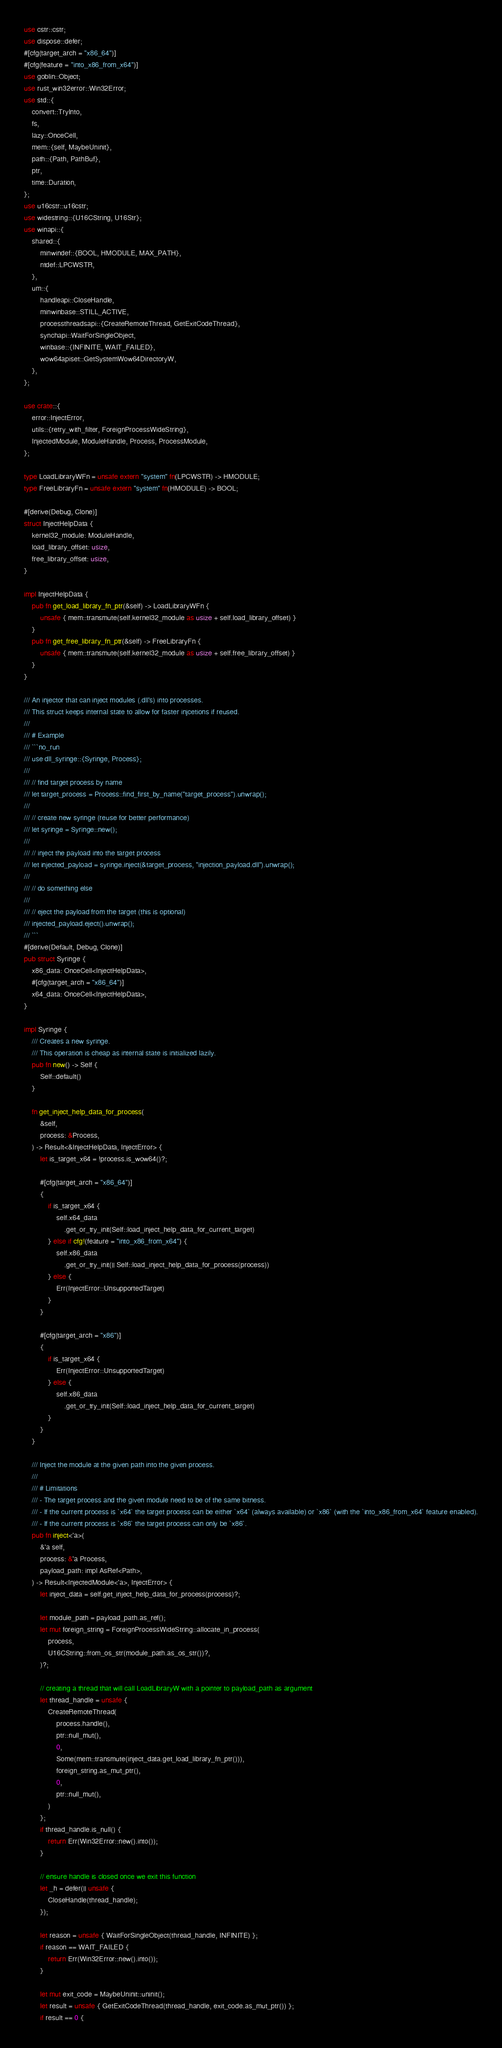<code> <loc_0><loc_0><loc_500><loc_500><_Rust_>use cstr::cstr;
use dispose::defer;
#[cfg(target_arch = "x86_64")]
#[cfg(feature = "into_x86_from_x64")]
use goblin::Object;
use rust_win32error::Win32Error;
use std::{
    convert::TryInto,
    fs,
    lazy::OnceCell,
    mem::{self, MaybeUninit},
    path::{Path, PathBuf},
    ptr,
    time::Duration,
};
use u16cstr::u16cstr;
use widestring::{U16CString, U16Str};
use winapi::{
    shared::{
        minwindef::{BOOL, HMODULE, MAX_PATH},
        ntdef::LPCWSTR,
    },
    um::{
        handleapi::CloseHandle,
        minwinbase::STILL_ACTIVE,
        processthreadsapi::{CreateRemoteThread, GetExitCodeThread},
        synchapi::WaitForSingleObject,
        winbase::{INFINITE, WAIT_FAILED},
        wow64apiset::GetSystemWow64DirectoryW,
    },
};

use crate::{
    error::InjectError,
    utils::{retry_with_filter, ForeignProcessWideString},
    InjectedModule, ModuleHandle, Process, ProcessModule,
};

type LoadLibraryWFn = unsafe extern "system" fn(LPCWSTR) -> HMODULE;
type FreeLibraryFn = unsafe extern "system" fn(HMODULE) -> BOOL;

#[derive(Debug, Clone)]
struct InjectHelpData {
    kernel32_module: ModuleHandle,
    load_library_offset: usize,
    free_library_offset: usize,
}

impl InjectHelpData {
    pub fn get_load_library_fn_ptr(&self) -> LoadLibraryWFn {
        unsafe { mem::transmute(self.kernel32_module as usize + self.load_library_offset) }
    }
    pub fn get_free_library_fn_ptr(&self) -> FreeLibraryFn {
        unsafe { mem::transmute(self.kernel32_module as usize + self.free_library_offset) }
    }
}

/// An injector that can inject modules (.dll's) into processes.
/// This struct keeps internal state to allow for faster injcetions if reused.
///
/// # Example
/// ```no_run
/// use dll_syringe::{Syringe, Process};
///
/// // find target process by name
/// let target_process = Process::find_first_by_name("target_process").unwrap();
///
/// // create new syringe (reuse for better performance)
/// let syringe = Syringe::new();
///
/// // inject the payload into the target process
/// let injected_payload = syringe.inject(&target_process, "injection_payload.dll").unwrap();
///
/// // do something else
///
/// // eject the payload from the target (this is optional)
/// injected_payload.eject().unwrap();
/// ```
#[derive(Default, Debug, Clone)]
pub struct Syringe {
    x86_data: OnceCell<InjectHelpData>,
    #[cfg(target_arch = "x86_64")]
    x64_data: OnceCell<InjectHelpData>,
}

impl Syringe {
    /// Creates a new syringe.
    /// This operation is cheap as internal state is initialized lazily.
    pub fn new() -> Self {
        Self::default()
    }

    fn get_inject_help_data_for_process(
        &self,
        process: &Process,
    ) -> Result<&InjectHelpData, InjectError> {
        let is_target_x64 = !process.is_wow64()?;

        #[cfg(target_arch = "x86_64")]
        {
            if is_target_x64 {
                self.x64_data
                    .get_or_try_init(Self::load_inject_help_data_for_current_target)
            } else if cfg!(feature = "into_x86_from_x64") {
                self.x86_data
                    .get_or_try_init(|| Self::load_inject_help_data_for_process(process))
            } else {
                Err(InjectError::UnsupportedTarget)
            }
        }

        #[cfg(target_arch = "x86")]
        {
            if is_target_x64 {
                Err(InjectError::UnsupportedTarget)
            } else {
                self.x86_data
                    .get_or_try_init(Self::load_inject_help_data_for_current_target)
            }
        }
    }

    /// Inject the module at the given path into the given process.
    ///
    /// # Limitations
    /// - The target process and the given module need to be of the same bitness.
    /// - If the current process is `x64` the target process can be either `x64` (always available) or `x86` (with the `into_x86_from_x64` feature enabled).
    /// - If the current process is `x86` the target process can only be `x86`.
    pub fn inject<'a>(
        &'a self,
        process: &'a Process,
        payload_path: impl AsRef<Path>,
    ) -> Result<InjectedModule<'a>, InjectError> {
        let inject_data = self.get_inject_help_data_for_process(process)?;

        let module_path = payload_path.as_ref();
        let mut foreign_string = ForeignProcessWideString::allocate_in_process(
            process,
            U16CString::from_os_str(module_path.as_os_str())?,
        )?;

        // creating a thread that will call LoadLibraryW with a pointer to payload_path as argument
        let thread_handle = unsafe {
            CreateRemoteThread(
                process.handle(),
                ptr::null_mut(),
                0,
                Some(mem::transmute(inject_data.get_load_library_fn_ptr())),
                foreign_string.as_mut_ptr(),
                0,
                ptr::null_mut(),
            )
        };
        if thread_handle.is_null() {
            return Err(Win32Error::new().into());
        }

        // ensure handle is closed once we exit this function
        let _h = defer(|| unsafe {
            CloseHandle(thread_handle);
        });

        let reason = unsafe { WaitForSingleObject(thread_handle, INFINITE) };
        if reason == WAIT_FAILED {
            return Err(Win32Error::new().into());
        }

        let mut exit_code = MaybeUninit::uninit();
        let result = unsafe { GetExitCodeThread(thread_handle, exit_code.as_mut_ptr()) };
        if result == 0 {</code> 